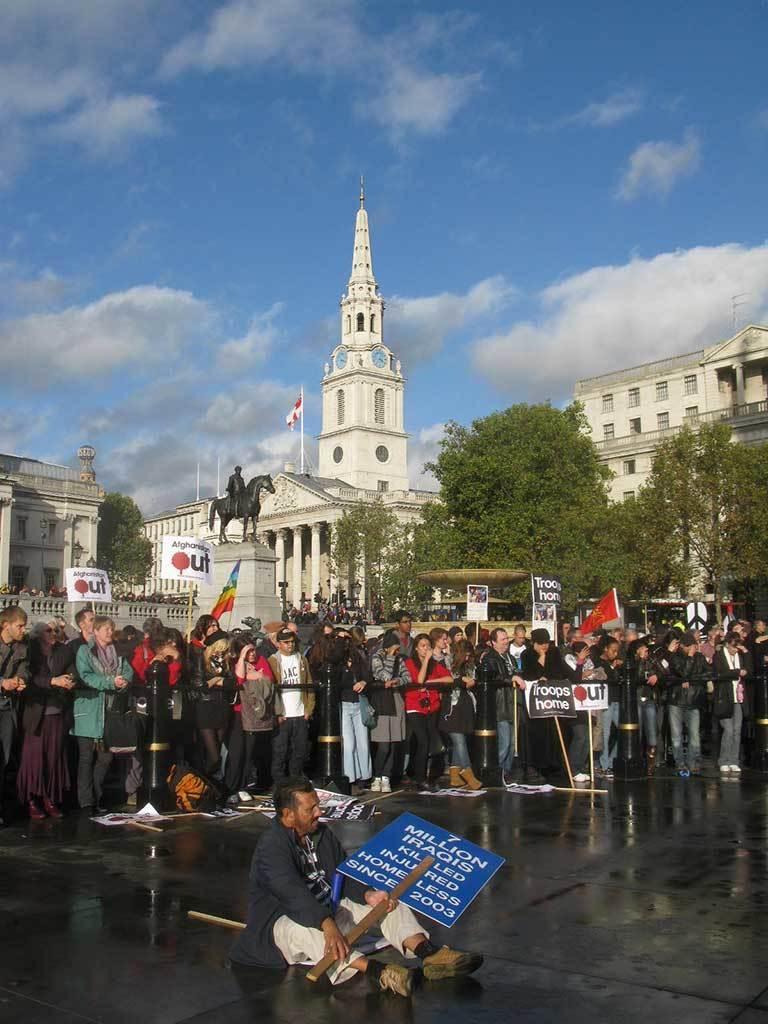Could you give a brief overview of what you see in this image? In the picture I can see a group of people are standing among them one person is sitting and others are standing on the ground. In the background I can see trees, a flag on a building, buildings, fence, the sky and some other objects. 